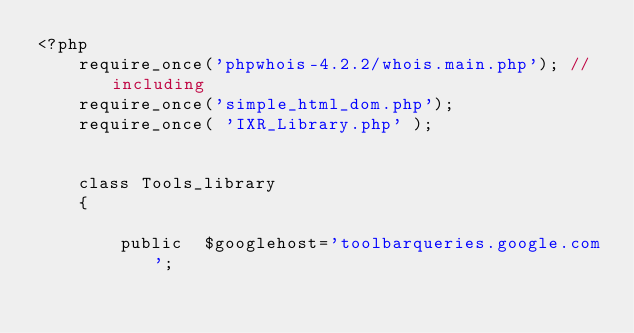<code> <loc_0><loc_0><loc_500><loc_500><_PHP_><?php  
    require_once('phpwhois-4.2.2/whois.main.php'); // including 
    require_once('simple_html_dom.php');
    require_once( 'IXR_Library.php' );


    class Tools_library
    {

        public  $googlehost='toolbarqueries.google.com';</code> 